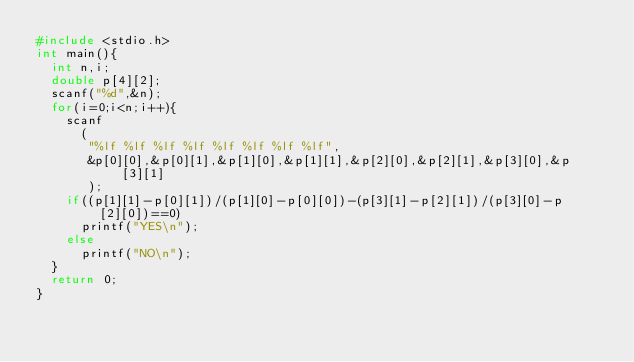Convert code to text. <code><loc_0><loc_0><loc_500><loc_500><_C_>#include <stdio.h>
int main(){
  int n,i;
  double p[4][2];
  scanf("%d",&n);
  for(i=0;i<n;i++){
    scanf
      (
       "%lf %lf %lf %lf %lf %lf %lf %lf",
       &p[0][0],&p[0][1],&p[1][0],&p[1][1],&p[2][0],&p[2][1],&p[3][0],&p[3][1]
       );
    if((p[1][1]-p[0][1])/(p[1][0]-p[0][0])-(p[3][1]-p[2][1])/(p[3][0]-p[2][0])==0)
      printf("YES\n");
    else 
      printf("NO\n");
  }
  return 0;
}</code> 